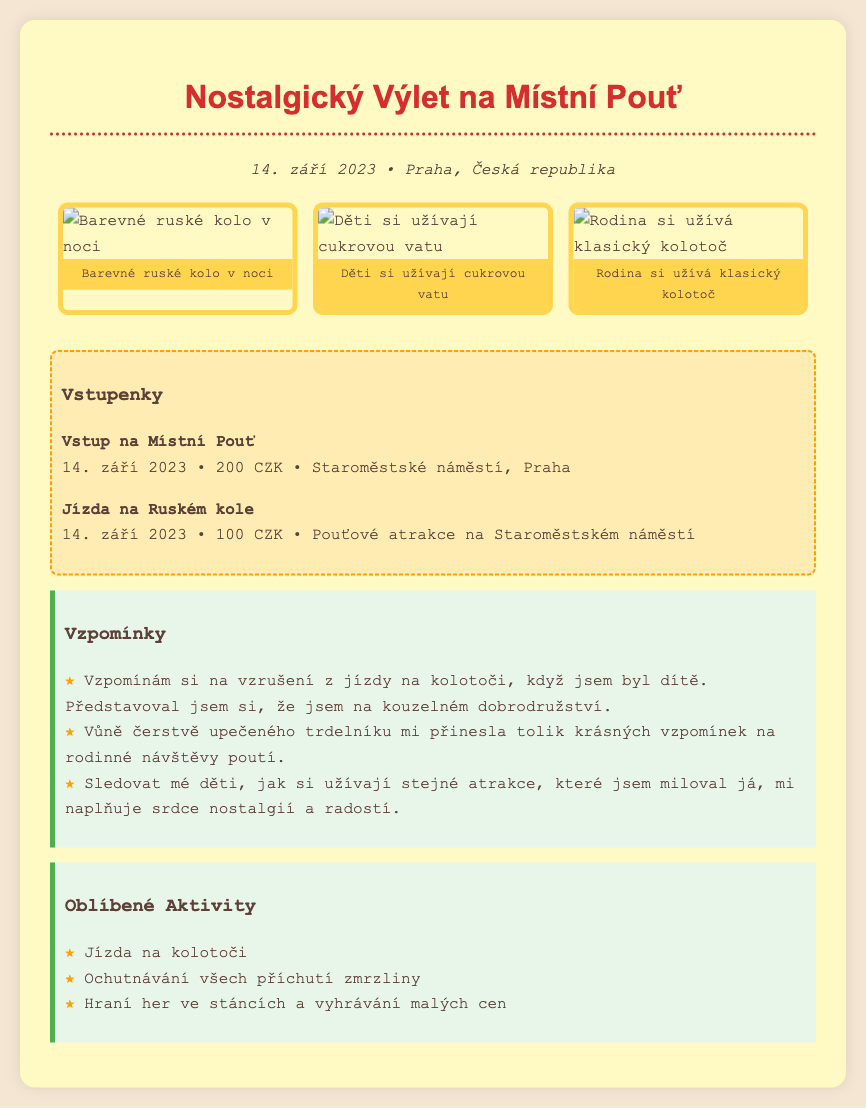What is the date of the local fair? The date of the local fair is stated in the document.
Answer: 14. září 2023 Where was the local fair held? The location of the local fair is mentioned in the document.
Answer: Praha, Česká republika How much did the entry ticket cost? The cost of the entry ticket is provided in the ticket stub section.
Answer: 200 CZK What activity is associated with the photo of the colorful Ferris wheel? The document describes the photo of the Ferris wheel and any related activities.
Answer: Jízda na Ruském kole Which activity evokes a sensation of nostalgia for the author? A specific activity that brings back memories for the author is listed in the reflections.
Answer: Jízda na kolotoči What favorite treat is mentioned in the reflections? The reflections highlight a specific food that evokes memories for the author.
Answer: Trdelník How many favorite activities are listed? The document contains a list of favorite activities, and the number is retrievable from that section.
Answer: 3 What is the theme of the scrapbook page? The main theme of the scrapbook reflects personal experiences at the fair.
Answer: Nostalgický Výlet What color is the background of the scrapbook document? The background color of the entire document is specified in the style section.
Answer: #f4e6d2 